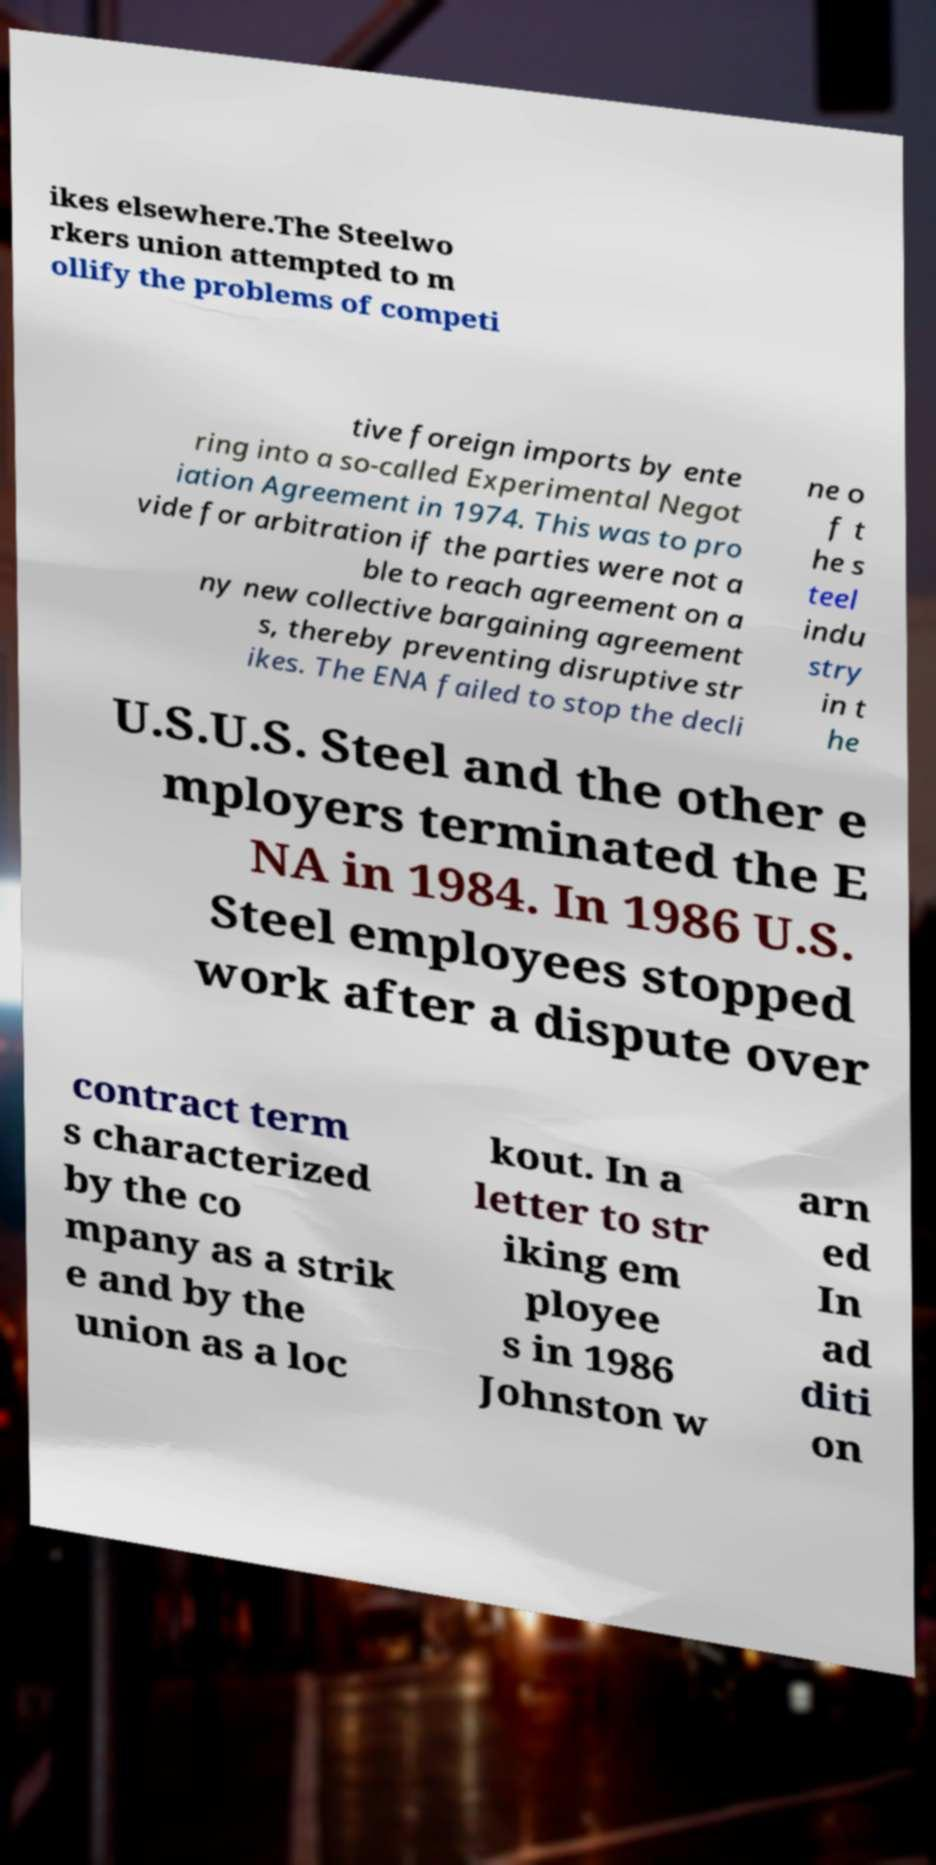Please identify and transcribe the text found in this image. ikes elsewhere.The Steelwo rkers union attempted to m ollify the problems of competi tive foreign imports by ente ring into a so-called Experimental Negot iation Agreement in 1974. This was to pro vide for arbitration if the parties were not a ble to reach agreement on a ny new collective bargaining agreement s, thereby preventing disruptive str ikes. The ENA failed to stop the decli ne o f t he s teel indu stry in t he U.S.U.S. Steel and the other e mployers terminated the E NA in 1984. In 1986 U.S. Steel employees stopped work after a dispute over contract term s characterized by the co mpany as a strik e and by the union as a loc kout. In a letter to str iking em ployee s in 1986 Johnston w arn ed In ad diti on 